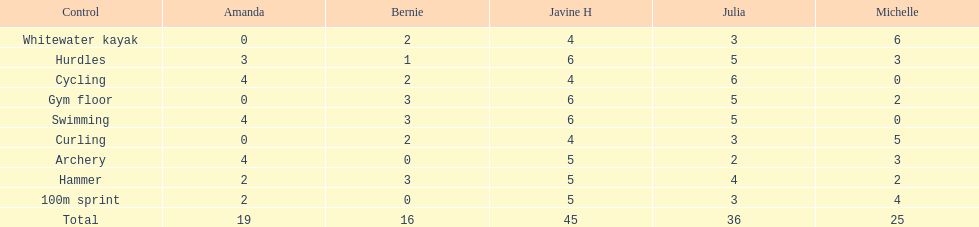Which of the girls had the least amount in archery? Bernie. 